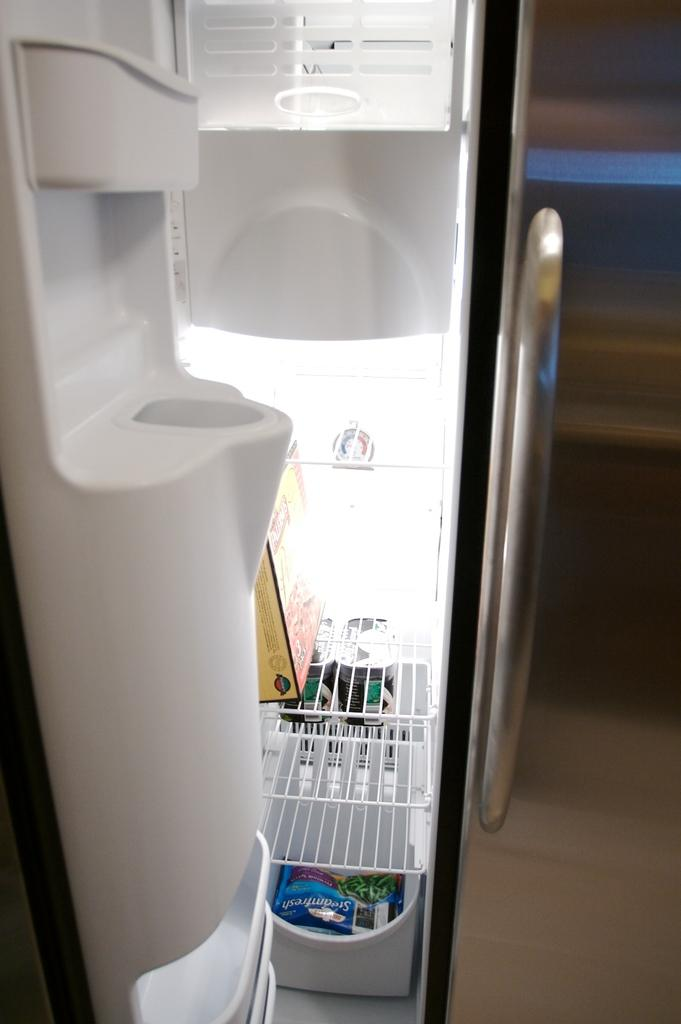What appliance can be seen in the image? There is a refrigerator in the image. What items are stored inside the refrigerator? Water bottles and packets are placed inside the refrigerator. Can you describe the background of the image? The background of the image is blurred. What type of plough is being used in the field in the image? There is no field or plough present in the image; it features a refrigerator with items inside. 